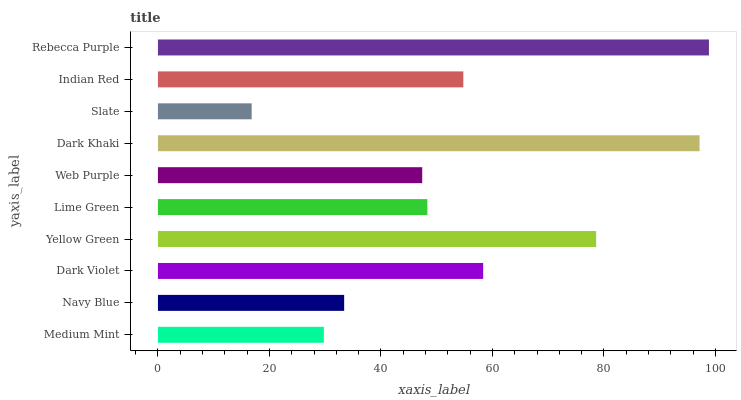Is Slate the minimum?
Answer yes or no. Yes. Is Rebecca Purple the maximum?
Answer yes or no. Yes. Is Navy Blue the minimum?
Answer yes or no. No. Is Navy Blue the maximum?
Answer yes or no. No. Is Navy Blue greater than Medium Mint?
Answer yes or no. Yes. Is Medium Mint less than Navy Blue?
Answer yes or no. Yes. Is Medium Mint greater than Navy Blue?
Answer yes or no. No. Is Navy Blue less than Medium Mint?
Answer yes or no. No. Is Indian Red the high median?
Answer yes or no. Yes. Is Lime Green the low median?
Answer yes or no. Yes. Is Slate the high median?
Answer yes or no. No. Is Indian Red the low median?
Answer yes or no. No. 